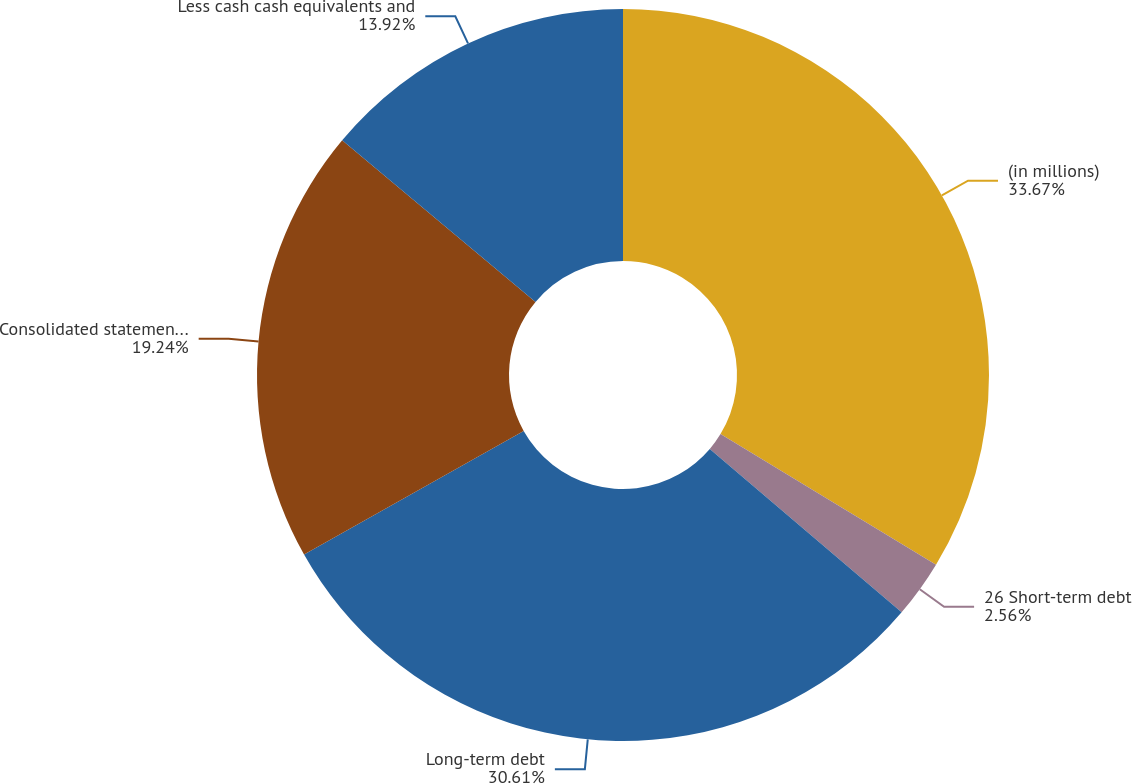Convert chart. <chart><loc_0><loc_0><loc_500><loc_500><pie_chart><fcel>(in millions)<fcel>26 Short-term debt<fcel>Long-term debt<fcel>Consolidated statements of<fcel>Less cash cash equivalents and<nl><fcel>33.67%<fcel>2.56%<fcel>30.61%<fcel>19.24%<fcel>13.92%<nl></chart> 